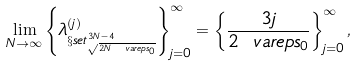Convert formula to latex. <formula><loc_0><loc_0><loc_500><loc_500>\lim _ { N \to \infty } \left \{ \lambda _ { \S s e t ^ { 3 N - 4 } _ { \sqrt { 2 N \ v a r e p s _ { 0 } } } } ^ { ( j ) } \right \} _ { j = 0 } ^ { \infty } = \left \{ \frac { 3 j } { 2 \ v a r e p s _ { 0 } } \right \} _ { j = 0 } ^ { \infty } ,</formula> 